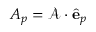Convert formula to latex. <formula><loc_0><loc_0><loc_500><loc_500>A _ { p } = \mathcal { A } \cdot \hat { e } _ { p }</formula> 